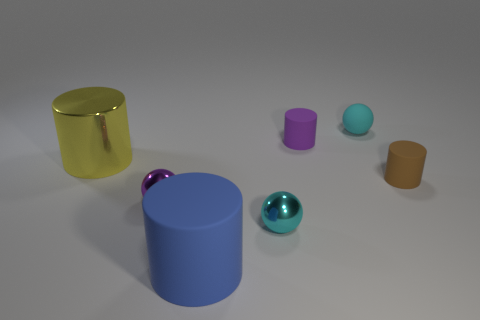What number of other metallic cylinders are the same size as the shiny cylinder?
Your response must be concise. 0. There is a cyan sphere that is behind the brown matte cylinder; does it have the same size as the cyan shiny sphere?
Provide a succinct answer. Yes. What is the shape of the large yellow metallic object?
Keep it short and to the point. Cylinder. What size is the object that is the same color as the tiny matte ball?
Offer a very short reply. Small. Are the small sphere that is behind the small brown matte object and the brown object made of the same material?
Ensure brevity in your answer.  Yes. Are there any cylinders of the same color as the big matte thing?
Offer a terse response. No. Does the tiny cyan object in front of the yellow cylinder have the same shape as the tiny cyan object that is behind the purple shiny sphere?
Offer a very short reply. Yes. Is there a purple object made of the same material as the big blue thing?
Your answer should be compact. Yes. How many blue things are large matte objects or small rubber balls?
Offer a very short reply. 1. How big is the shiny thing that is both to the left of the large blue cylinder and right of the big metal cylinder?
Make the answer very short. Small. 